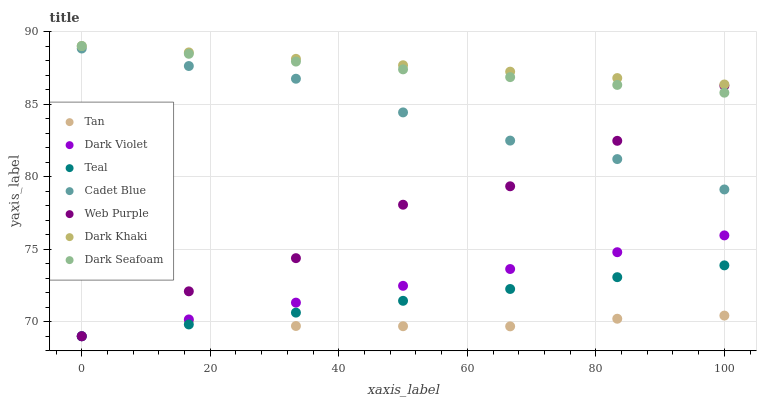Does Tan have the minimum area under the curve?
Answer yes or no. Yes. Does Dark Khaki have the maximum area under the curve?
Answer yes or no. Yes. Does Dark Seafoam have the minimum area under the curve?
Answer yes or no. No. Does Dark Seafoam have the maximum area under the curve?
Answer yes or no. No. Is Dark Khaki the smoothest?
Answer yes or no. Yes. Is Web Purple the roughest?
Answer yes or no. Yes. Is Dark Seafoam the smoothest?
Answer yes or no. No. Is Dark Seafoam the roughest?
Answer yes or no. No. Does Dark Violet have the lowest value?
Answer yes or no. Yes. Does Dark Seafoam have the lowest value?
Answer yes or no. No. Does Dark Khaki have the highest value?
Answer yes or no. Yes. Does Dark Violet have the highest value?
Answer yes or no. No. Is Cadet Blue less than Dark Khaki?
Answer yes or no. Yes. Is Dark Seafoam greater than Cadet Blue?
Answer yes or no. Yes. Does Dark Violet intersect Teal?
Answer yes or no. Yes. Is Dark Violet less than Teal?
Answer yes or no. No. Is Dark Violet greater than Teal?
Answer yes or no. No. Does Cadet Blue intersect Dark Khaki?
Answer yes or no. No. 